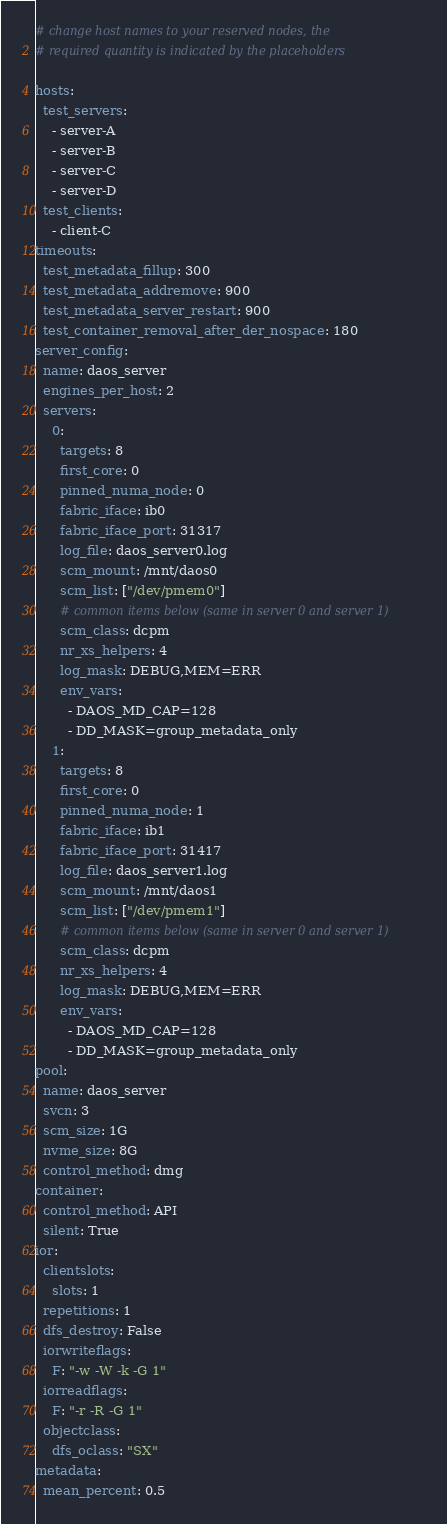Convert code to text. <code><loc_0><loc_0><loc_500><loc_500><_YAML_># change host names to your reserved nodes, the
# required quantity is indicated by the placeholders

hosts:
  test_servers:
    - server-A
    - server-B
    - server-C
    - server-D
  test_clients:
    - client-C
timeouts:
  test_metadata_fillup: 300
  test_metadata_addremove: 900
  test_metadata_server_restart: 900
  test_container_removal_after_der_nospace: 180
server_config:
  name: daos_server
  engines_per_host: 2
  servers:
    0:
      targets: 8
      first_core: 0
      pinned_numa_node: 0
      fabric_iface: ib0
      fabric_iface_port: 31317
      log_file: daos_server0.log
      scm_mount: /mnt/daos0
      scm_list: ["/dev/pmem0"]
      # common items below (same in server 0 and server 1)
      scm_class: dcpm
      nr_xs_helpers: 4
      log_mask: DEBUG,MEM=ERR
      env_vars:
        - DAOS_MD_CAP=128
        - DD_MASK=group_metadata_only
    1:
      targets: 8
      first_core: 0
      pinned_numa_node: 1
      fabric_iface: ib1
      fabric_iface_port: 31417
      log_file: daos_server1.log
      scm_mount: /mnt/daos1
      scm_list: ["/dev/pmem1"]
      # common items below (same in server 0 and server 1)
      scm_class: dcpm
      nr_xs_helpers: 4
      log_mask: DEBUG,MEM=ERR
      env_vars:
        - DAOS_MD_CAP=128
        - DD_MASK=group_metadata_only
pool:
  name: daos_server
  svcn: 3
  scm_size: 1G
  nvme_size: 8G
  control_method: dmg
container:
  control_method: API
  silent: True
ior:
  clientslots:
    slots: 1
  repetitions: 1
  dfs_destroy: False
  iorwriteflags:
    F: "-w -W -k -G 1"
  iorreadflags:
    F: "-r -R -G 1"
  objectclass:
    dfs_oclass: "SX"
metadata:
  mean_percent: 0.5
</code> 